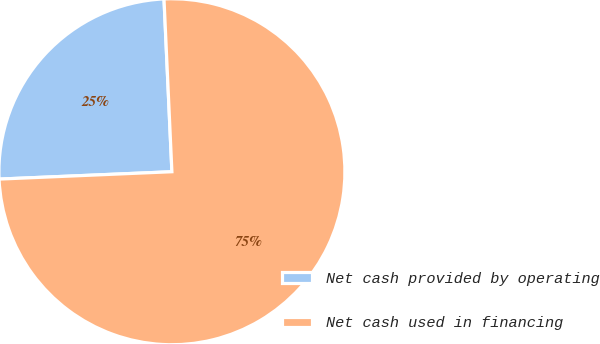<chart> <loc_0><loc_0><loc_500><loc_500><pie_chart><fcel>Net cash provided by operating<fcel>Net cash used in financing<nl><fcel>24.95%<fcel>75.05%<nl></chart> 